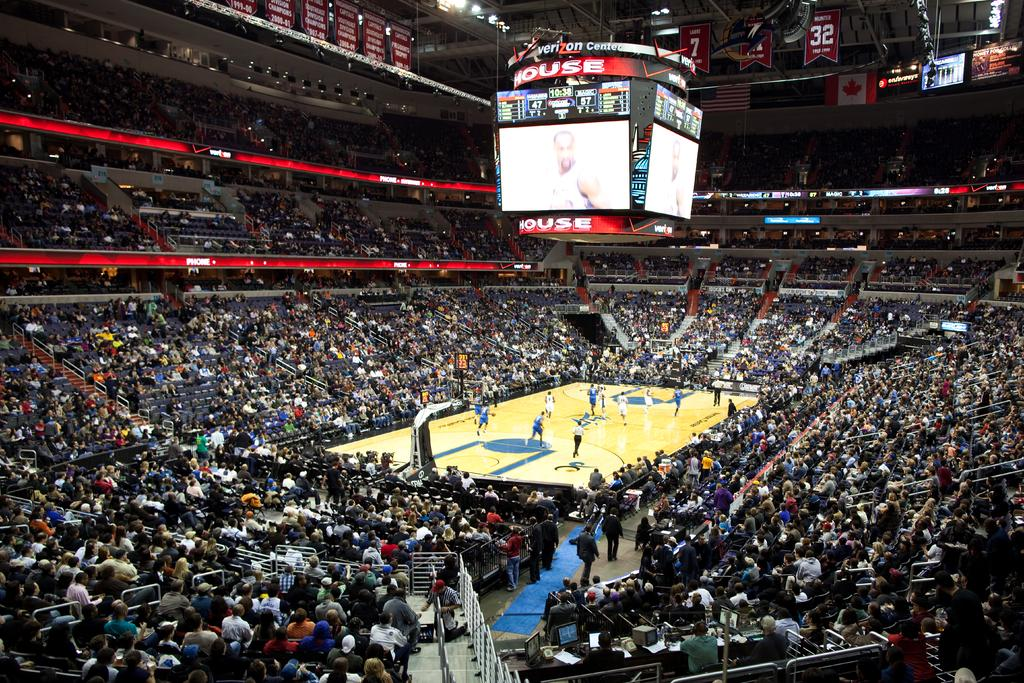<image>
Offer a succinct explanation of the picture presented. Sports stadium that has a scoreboard that says "House" on the bottom. 